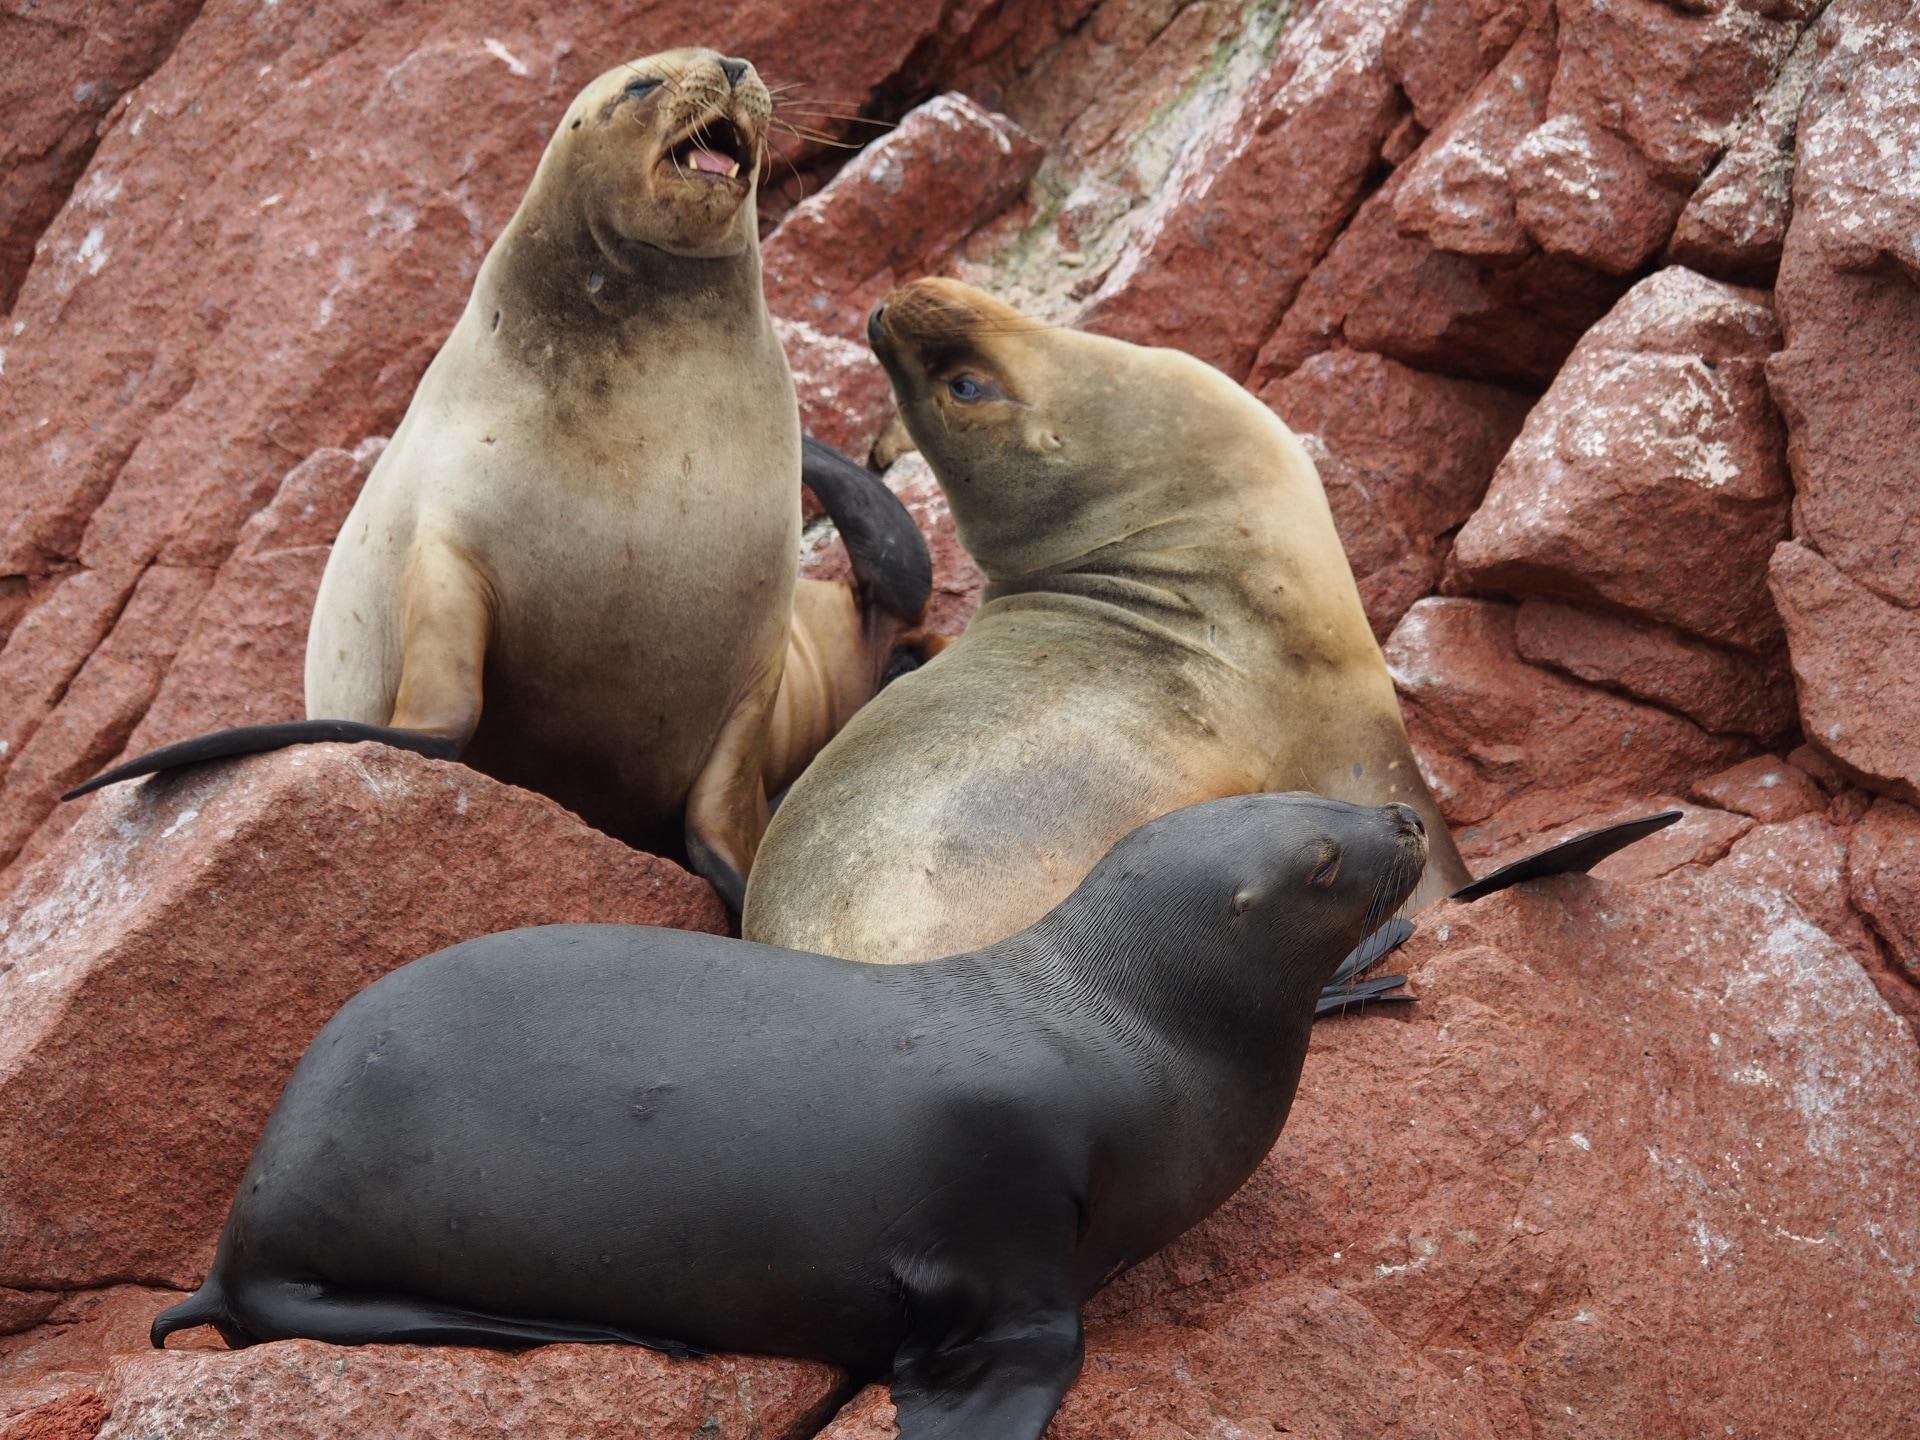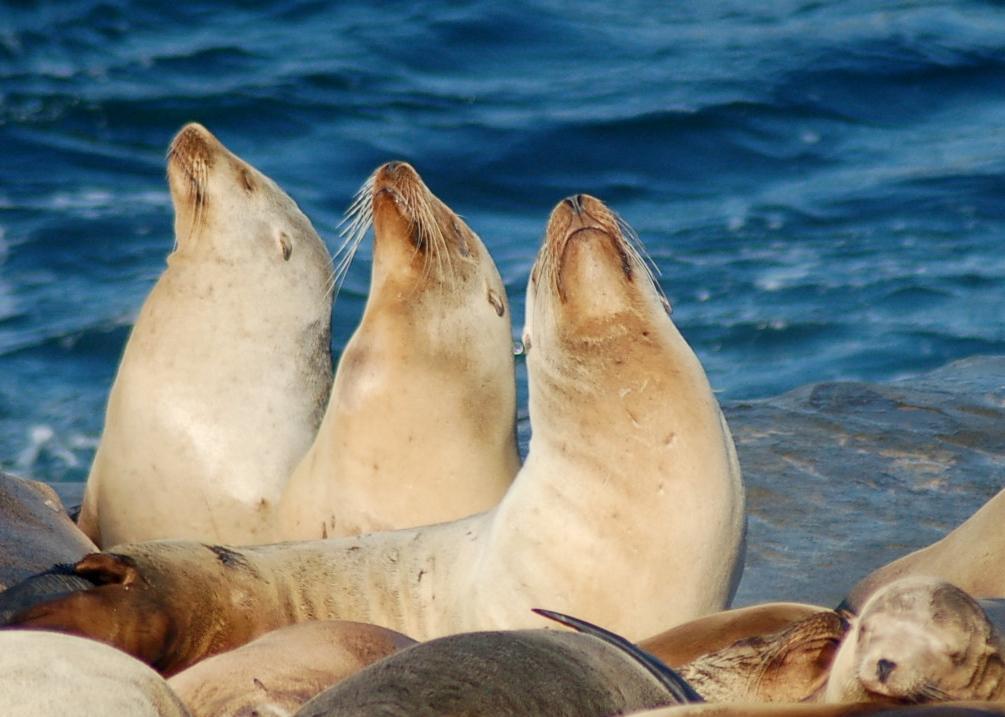The first image is the image on the left, the second image is the image on the right. For the images displayed, is the sentence "The left image contains exactly two seals." factually correct? Answer yes or no. No. The first image is the image on the left, the second image is the image on the right. Evaluate the accuracy of this statement regarding the images: "There are 5 sea lions in total.". Is it true? Answer yes or no. No. 